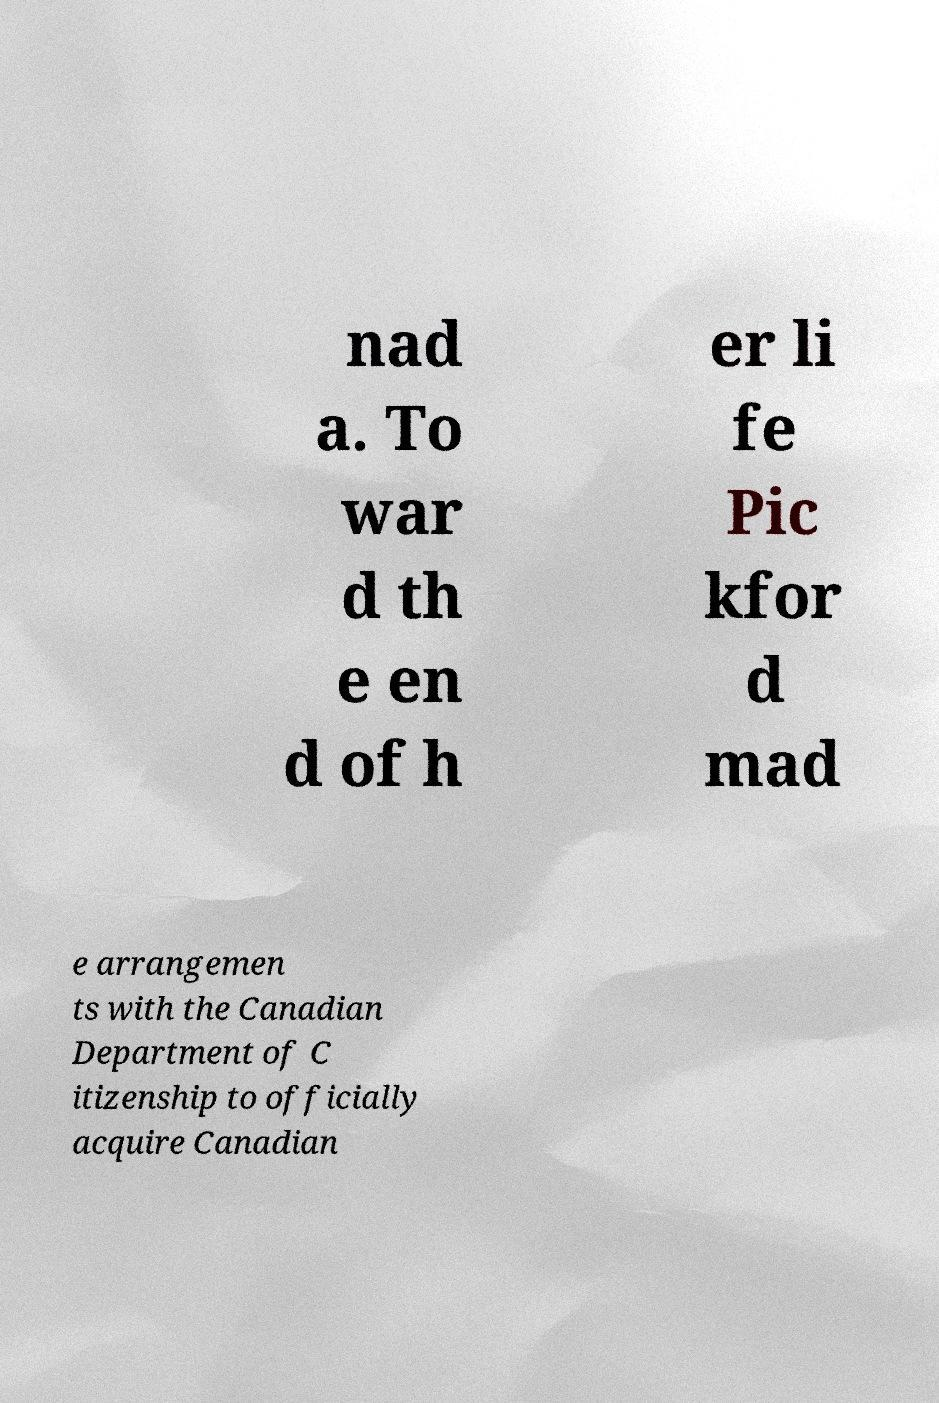What messages or text are displayed in this image? I need them in a readable, typed format. nad a. To war d th e en d of h er li fe Pic kfor d mad e arrangemen ts with the Canadian Department of C itizenship to officially acquire Canadian 